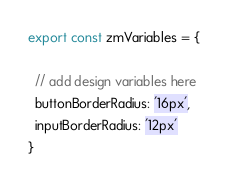Convert code to text. <code><loc_0><loc_0><loc_500><loc_500><_JavaScript_>export const zmVariables = {

  // add design variables here
  buttonBorderRadius: '16px',
  inputBorderRadius: '12px'
}
</code> 